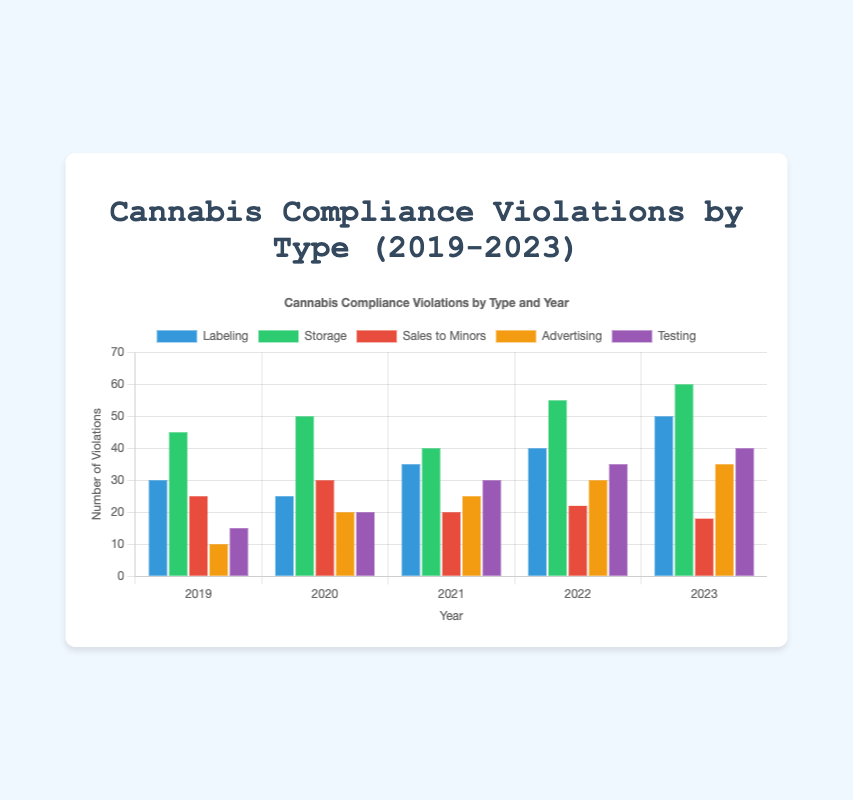Which type of cannabis compliance violation had the highest number in 2023? In 2023, the violation with the highest number is visible by comparing the heights of the bars for each type. "Storage" has the highest bar.
Answer: Storage How many labeling violations were reported in total from 2019 to 2023? Sum the labeling violations across all years: 30 (2019) + 25 (2020) + 35 (2021) + 40 (2022) + 50 (2023). This totals to 180.
Answer: 180 Between which two consecutive years was the largest increase in advertising violations observed? Compare the increase in advertising violations year-over-year: 
2019-2020: 10 to 20 (+10), 
2020-2021: 20 to 25 (+5), 
2021-2022: 25 to 30 (+5), 
2022-2023: 30 to 35 (+5). 
The largest increase was from 2019 to 2020.
Answer: 2019 to 2020 Which year had the lowest number of testing violations? By observing the heights of the bars representing testing violations each year, the lowest is in 2019 with 15 violations.
Answer: 2019 What is the total number of violations in 2021 across all types? Sum the violations of all types for 2021: 35 (labeling) + 40 (storage) + 20 (sales to minors) + 25 (advertising) + 30 (testing). This gives a total of 150.
Answer: 150 Was there any year where advertising violations were equal to labeling violations? By comparing the heights of the bars representing advertising and labeling violations for each year, we find that there is no year where these two are equal.
Answer: No What is the difference in the total number of violations between 2020 and 2019? Sum the violations across all types for both years and find the difference: 
2019: 30 + 45 + 25 + 10 + 15 = 125, 
2020: 25 + 50 + 30 + 20 + 20 = 145. 
Hence, the difference is 145 - 125 = 20.
Answer: 20 In which year did sales to minors violations decrease the most? Compare the decrease across the years for sales to minors: 
2019-2020: 25 to 30 (+5), 
2020-2021: 30 to 20 (-10), 
2021-2022: 20 to 22 (+2), 
2022-2023: 22 to 18 (-4), 
The largest decrease is from 2020 to 2021.
Answer: 2020 to 2021 Which type of violation saw the most consistent yearly increase from 2019 to 2023? By observing the trends for each type: 
Labeling: 30 to 25 to 35 to 40 to 50 (inconsistency from 2019 to 2020), 
Storage: 45 to 50 to 40 to 55 to 60 (decrease in 2021), 
Sales to Minors: 25 to 30 to 20 to 22 to 18 (several inconsistencies), 
Advertising: consistently increasing every year from 10 to 35, 
Testing: 15 to 20 to 30 to 35 to 40 (consistent increase).
Both "Advertising" and "Testing" have consistent increases but "Advertising" is consistently rising every year with no decline.
Answer: Advertising 